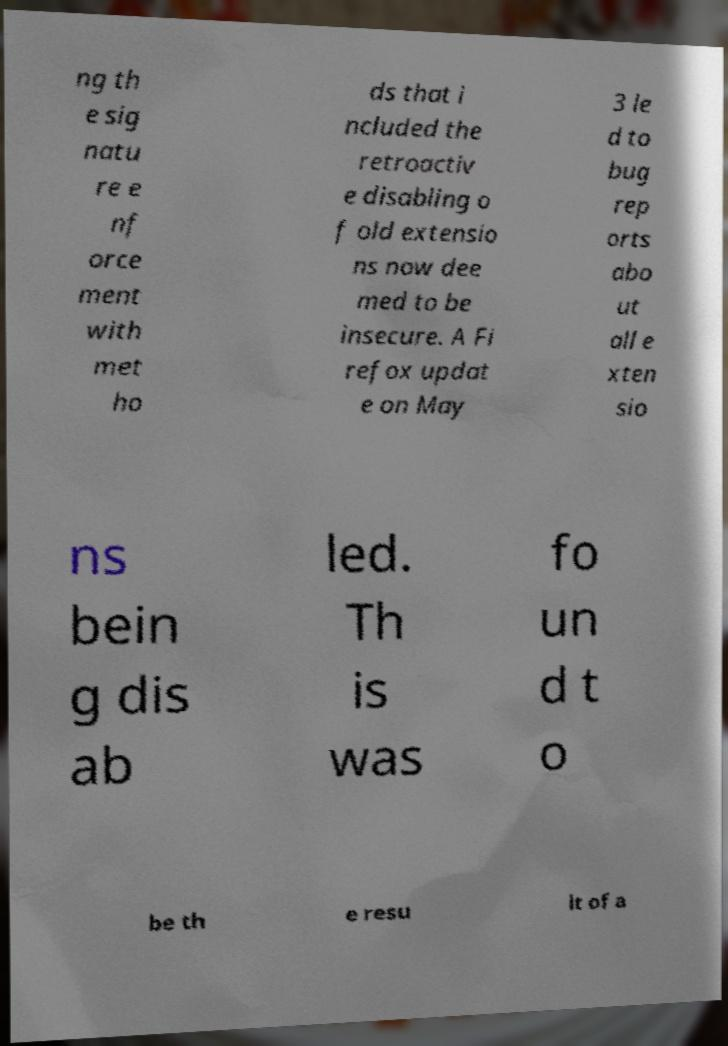For documentation purposes, I need the text within this image transcribed. Could you provide that? ng th e sig natu re e nf orce ment with met ho ds that i ncluded the retroactiv e disabling o f old extensio ns now dee med to be insecure. A Fi refox updat e on May 3 le d to bug rep orts abo ut all e xten sio ns bein g dis ab led. Th is was fo un d t o be th e resu lt of a 